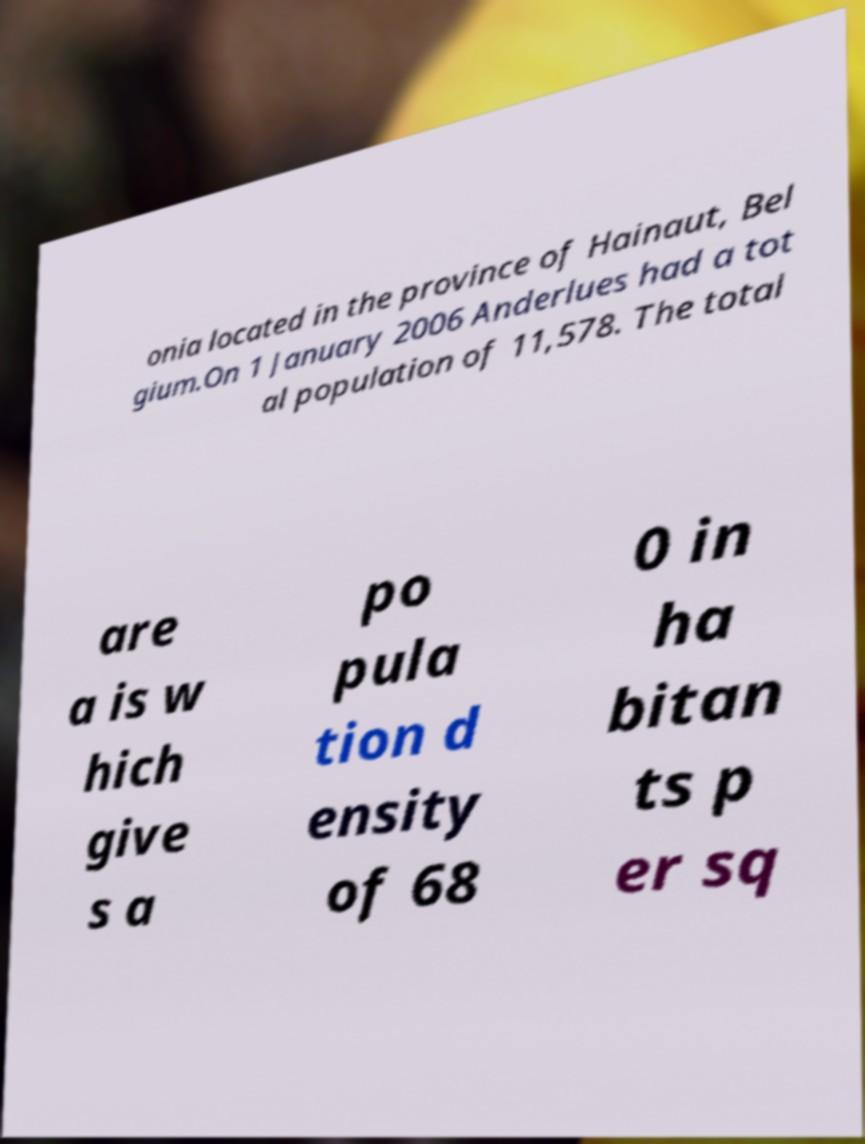I need the written content from this picture converted into text. Can you do that? onia located in the province of Hainaut, Bel gium.On 1 January 2006 Anderlues had a tot al population of 11,578. The total are a is w hich give s a po pula tion d ensity of 68 0 in ha bitan ts p er sq 